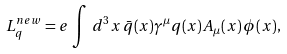Convert formula to latex. <formula><loc_0><loc_0><loc_500><loc_500>L ^ { n e w } _ { q } = e \, \int \, d ^ { 3 } x \, \bar { q } ( x ) \gamma ^ { \mu } q ( x ) A _ { \mu } ( x ) \, \phi ( x ) ,</formula> 